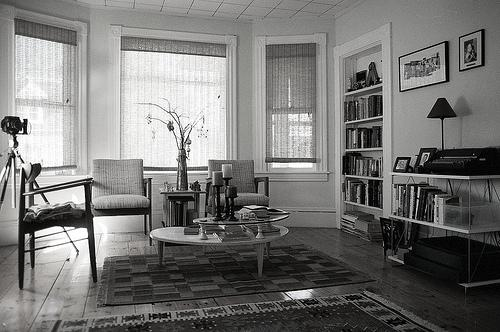Question: what room is it?
Choices:
A. Living room.
B. Bathroom.
C. Bedroom.
D. Kitchen.
Answer with the letter. Answer: A Question: how many people are there?
Choices:
A. 4.
B. None.
C. 5.
D. 9.
Answer with the letter. Answer: B Question: who is in the photo?
Choices:
A. A man.
B. A woman.
C. No one.
D. A little boy and girl.
Answer with the letter. Answer: C Question: what is below the table?
Choices:
A. Dog.
B. Food.
C. Tile.
D. Rug.
Answer with the letter. Answer: D Question: where was the photo taken?
Choices:
A. In the shower.
B. In a spaceship.
C. A room.
D. At a circus.
Answer with the letter. Answer: C 